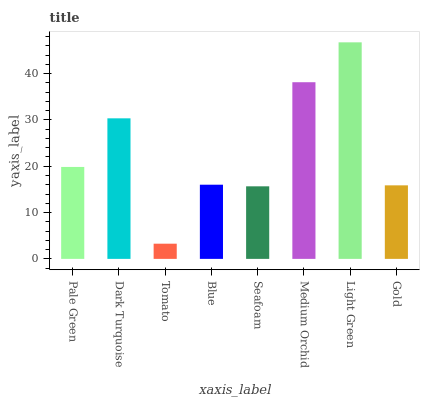Is Dark Turquoise the minimum?
Answer yes or no. No. Is Dark Turquoise the maximum?
Answer yes or no. No. Is Dark Turquoise greater than Pale Green?
Answer yes or no. Yes. Is Pale Green less than Dark Turquoise?
Answer yes or no. Yes. Is Pale Green greater than Dark Turquoise?
Answer yes or no. No. Is Dark Turquoise less than Pale Green?
Answer yes or no. No. Is Pale Green the high median?
Answer yes or no. Yes. Is Blue the low median?
Answer yes or no. Yes. Is Blue the high median?
Answer yes or no. No. Is Medium Orchid the low median?
Answer yes or no. No. 